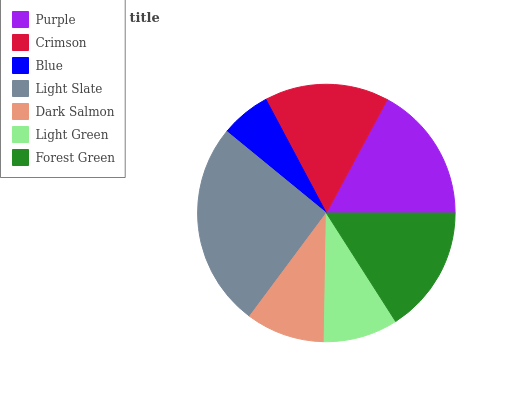Is Blue the minimum?
Answer yes or no. Yes. Is Light Slate the maximum?
Answer yes or no. Yes. Is Crimson the minimum?
Answer yes or no. No. Is Crimson the maximum?
Answer yes or no. No. Is Purple greater than Crimson?
Answer yes or no. Yes. Is Crimson less than Purple?
Answer yes or no. Yes. Is Crimson greater than Purple?
Answer yes or no. No. Is Purple less than Crimson?
Answer yes or no. No. Is Crimson the high median?
Answer yes or no. Yes. Is Crimson the low median?
Answer yes or no. Yes. Is Forest Green the high median?
Answer yes or no. No. Is Dark Salmon the low median?
Answer yes or no. No. 